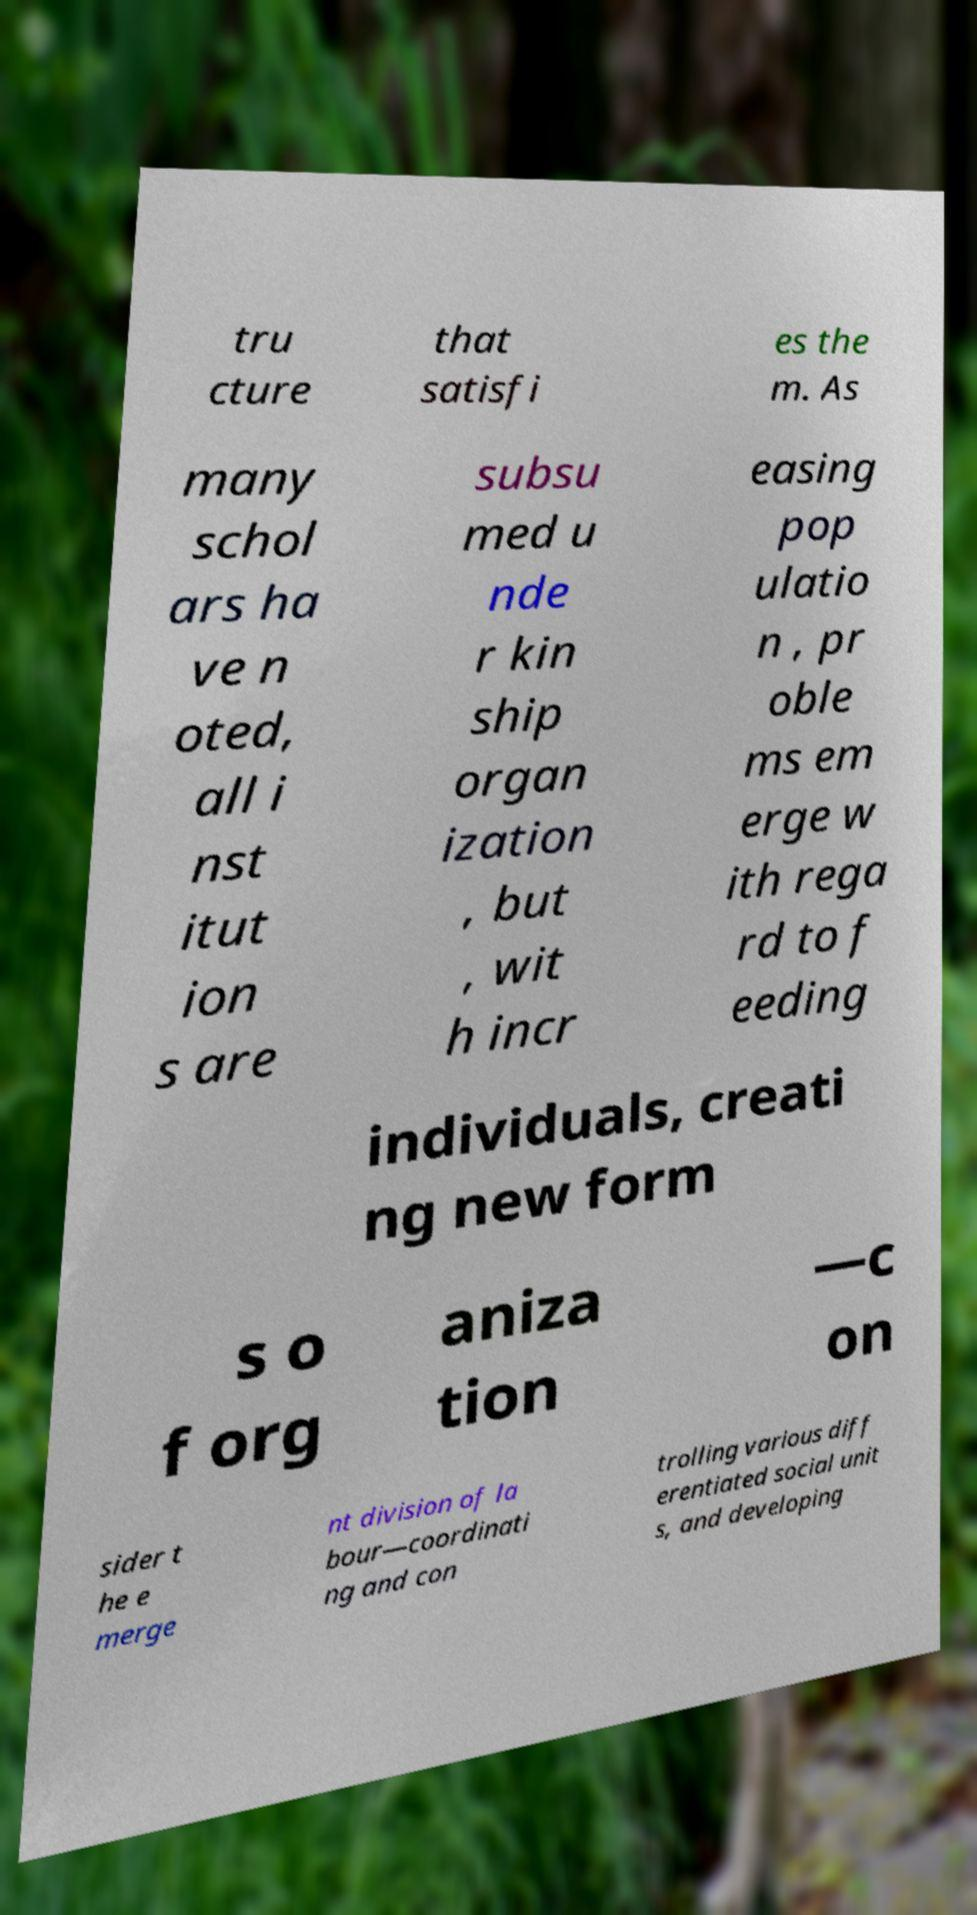There's text embedded in this image that I need extracted. Can you transcribe it verbatim? tru cture that satisfi es the m. As many schol ars ha ve n oted, all i nst itut ion s are subsu med u nde r kin ship organ ization , but , wit h incr easing pop ulatio n , pr oble ms em erge w ith rega rd to f eeding individuals, creati ng new form s o f org aniza tion —c on sider t he e merge nt division of la bour—coordinati ng and con trolling various diff erentiated social unit s, and developing 